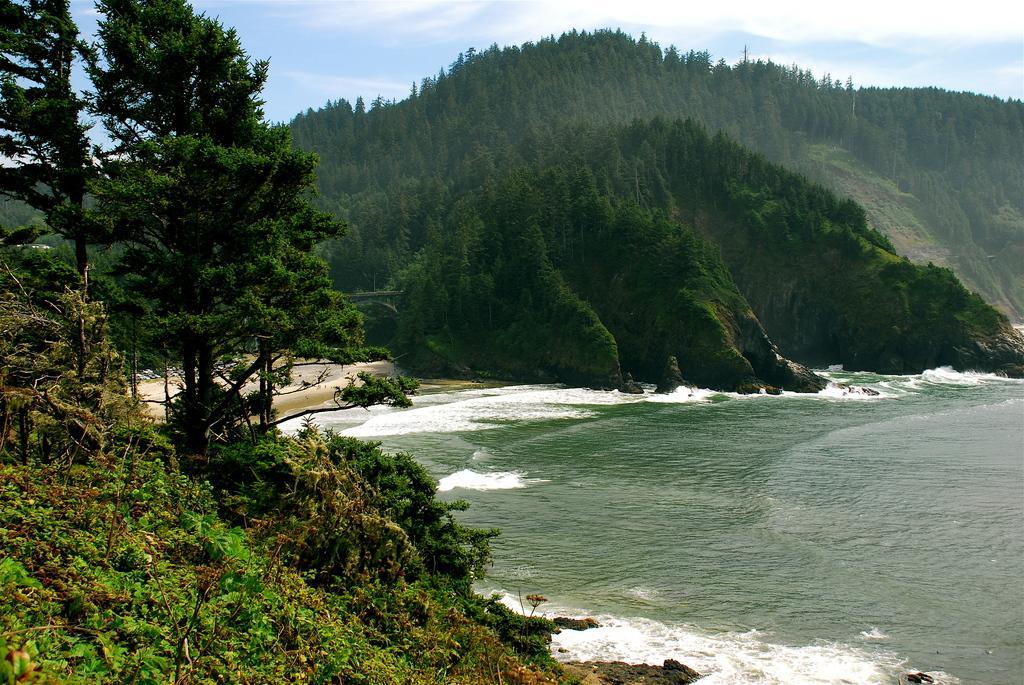Describe this image in one or two sentences. In this image we can see some plants and trees and on the right side, we can see the ocean. There are some mountains in the background and we can see the sky at the top. 